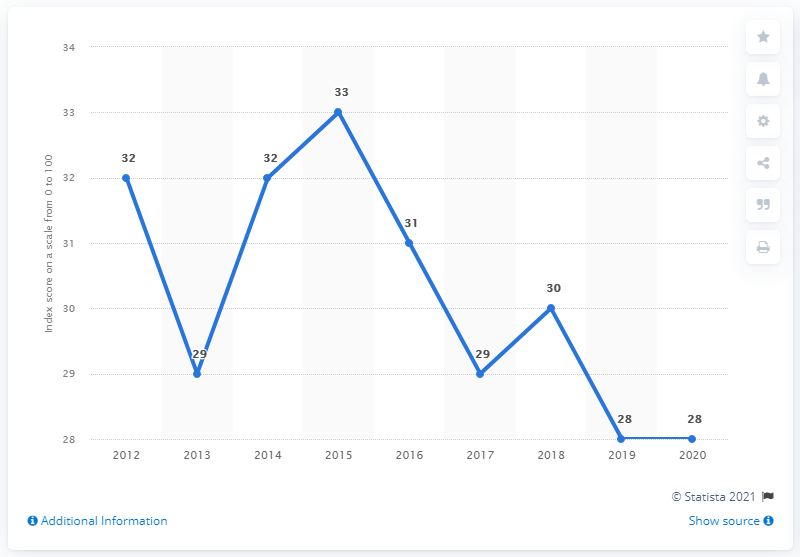How does the trend in the graph reflect the changes in the Dominican Republic's corruption perception over the years, and what might be the implications of such scores? The line graph indicates fluctuations in the Corruption Perception Index score of the Dominican Republic over the years, with a peak score of 33 in 2016 followed by a decline to 28 by 2019 and 2020. These scores may suggest that while there have been attempts at reform and periods of improvement, challenges remain in effectively combating corruption. Persistent low scores can harm the country's international reputation, deter investment, and hinder development. 